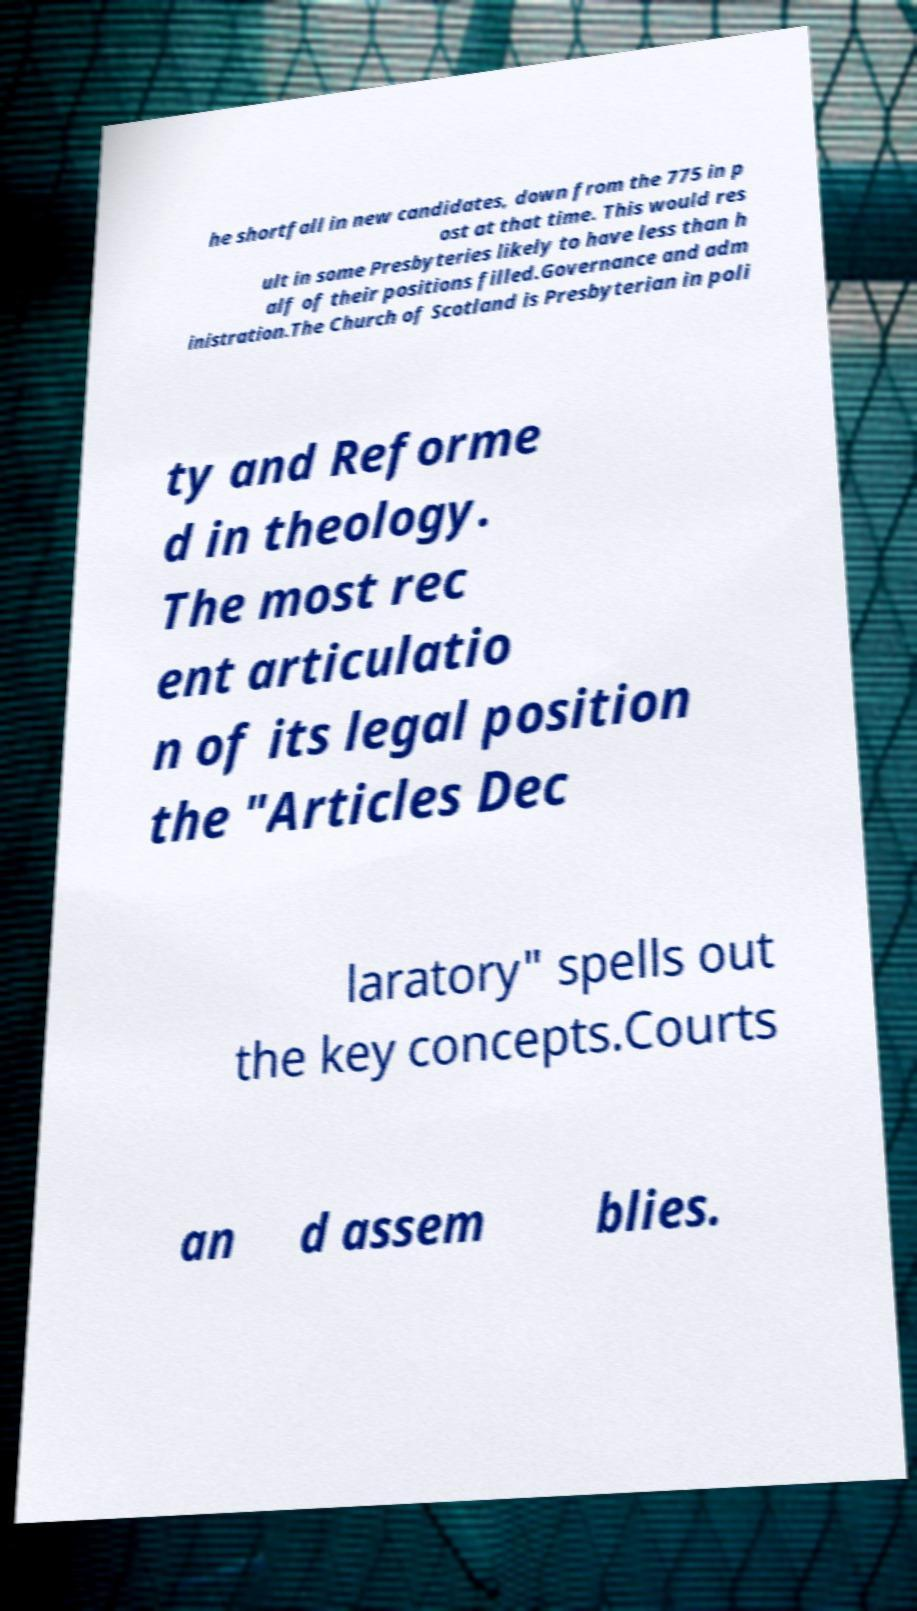Can you accurately transcribe the text from the provided image for me? he shortfall in new candidates, down from the 775 in p ost at that time. This would res ult in some Presbyteries likely to have less than h alf of their positions filled.Governance and adm inistration.The Church of Scotland is Presbyterian in poli ty and Reforme d in theology. The most rec ent articulatio n of its legal position the "Articles Dec laratory" spells out the key concepts.Courts an d assem blies. 